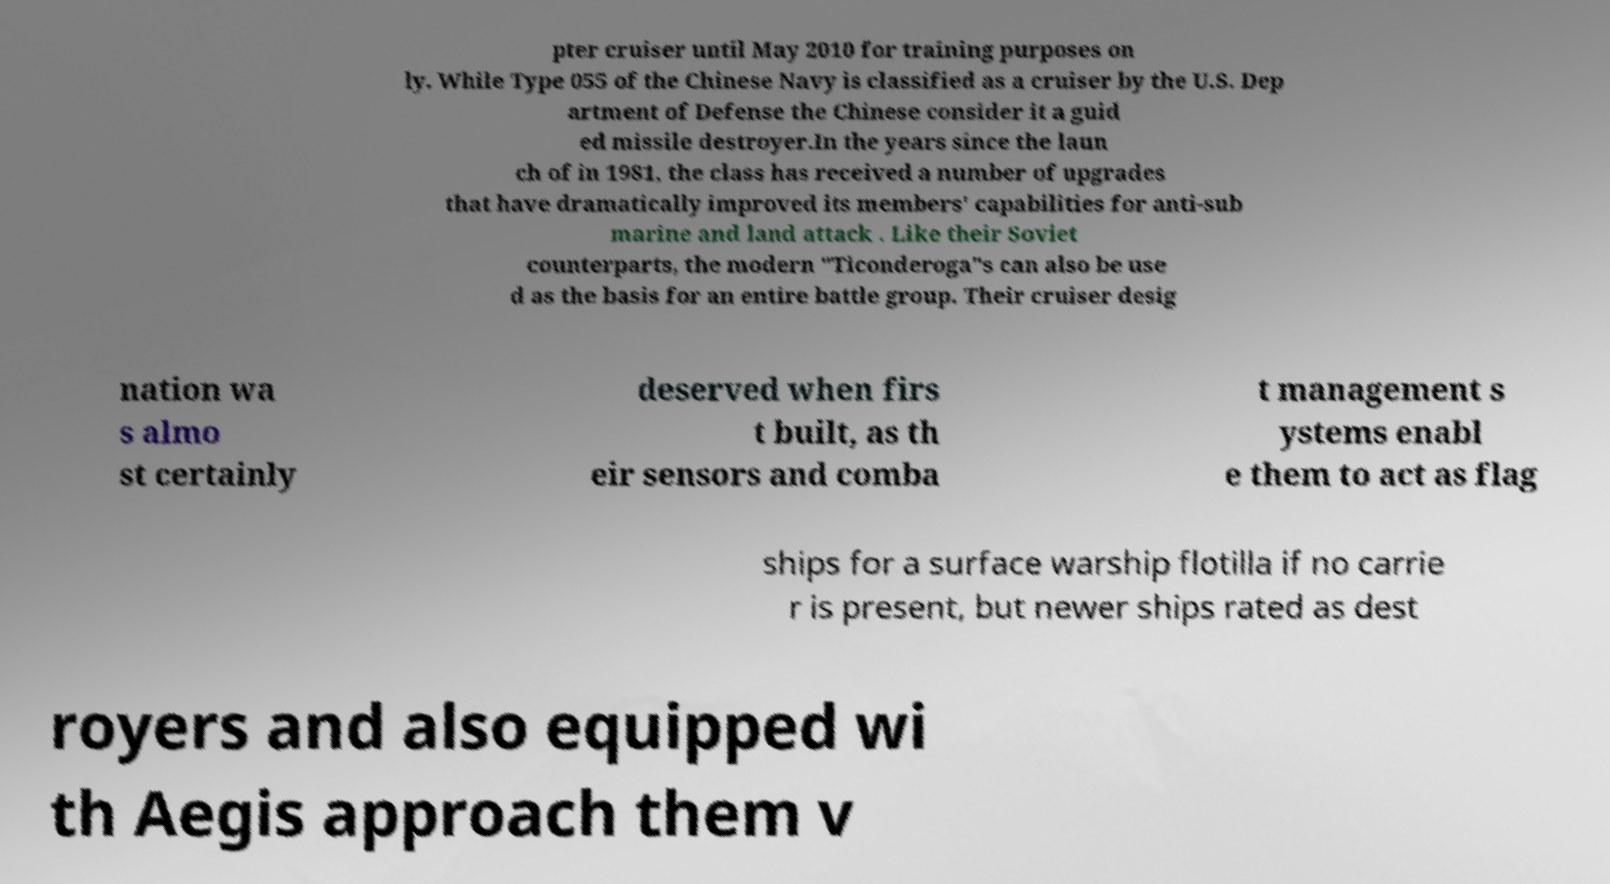Please identify and transcribe the text found in this image. pter cruiser until May 2010 for training purposes on ly. While Type 055 of the Chinese Navy is classified as a cruiser by the U.S. Dep artment of Defense the Chinese consider it a guid ed missile destroyer.In the years since the laun ch of in 1981, the class has received a number of upgrades that have dramatically improved its members' capabilities for anti-sub marine and land attack . Like their Soviet counterparts, the modern "Ticonderoga"s can also be use d as the basis for an entire battle group. Their cruiser desig nation wa s almo st certainly deserved when firs t built, as th eir sensors and comba t management s ystems enabl e them to act as flag ships for a surface warship flotilla if no carrie r is present, but newer ships rated as dest royers and also equipped wi th Aegis approach them v 